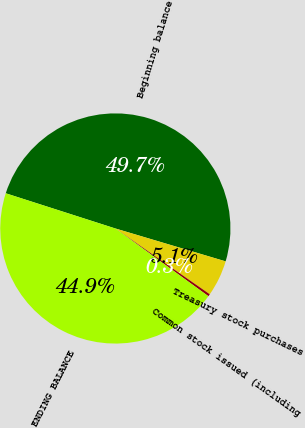Convert chart. <chart><loc_0><loc_0><loc_500><loc_500><pie_chart><fcel>Beginning balance<fcel>Treasury stock purchases<fcel>Common stock issued (including<fcel>ENDING BALANCE<nl><fcel>49.67%<fcel>5.07%<fcel>0.33%<fcel>44.93%<nl></chart> 